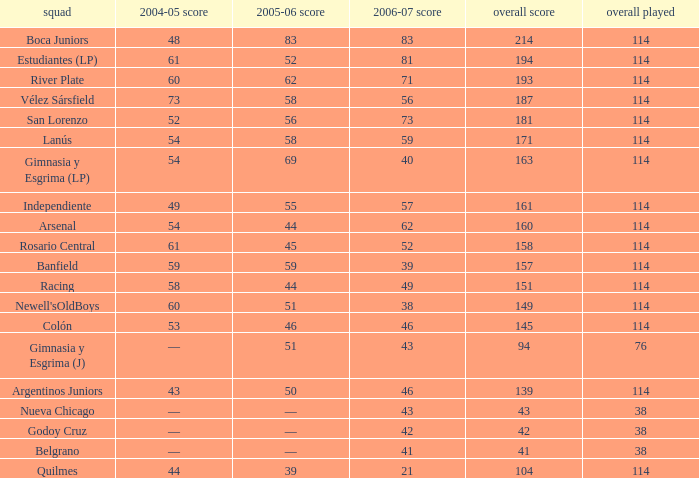What is the total number of points for a total pld less than 38? 0.0. 